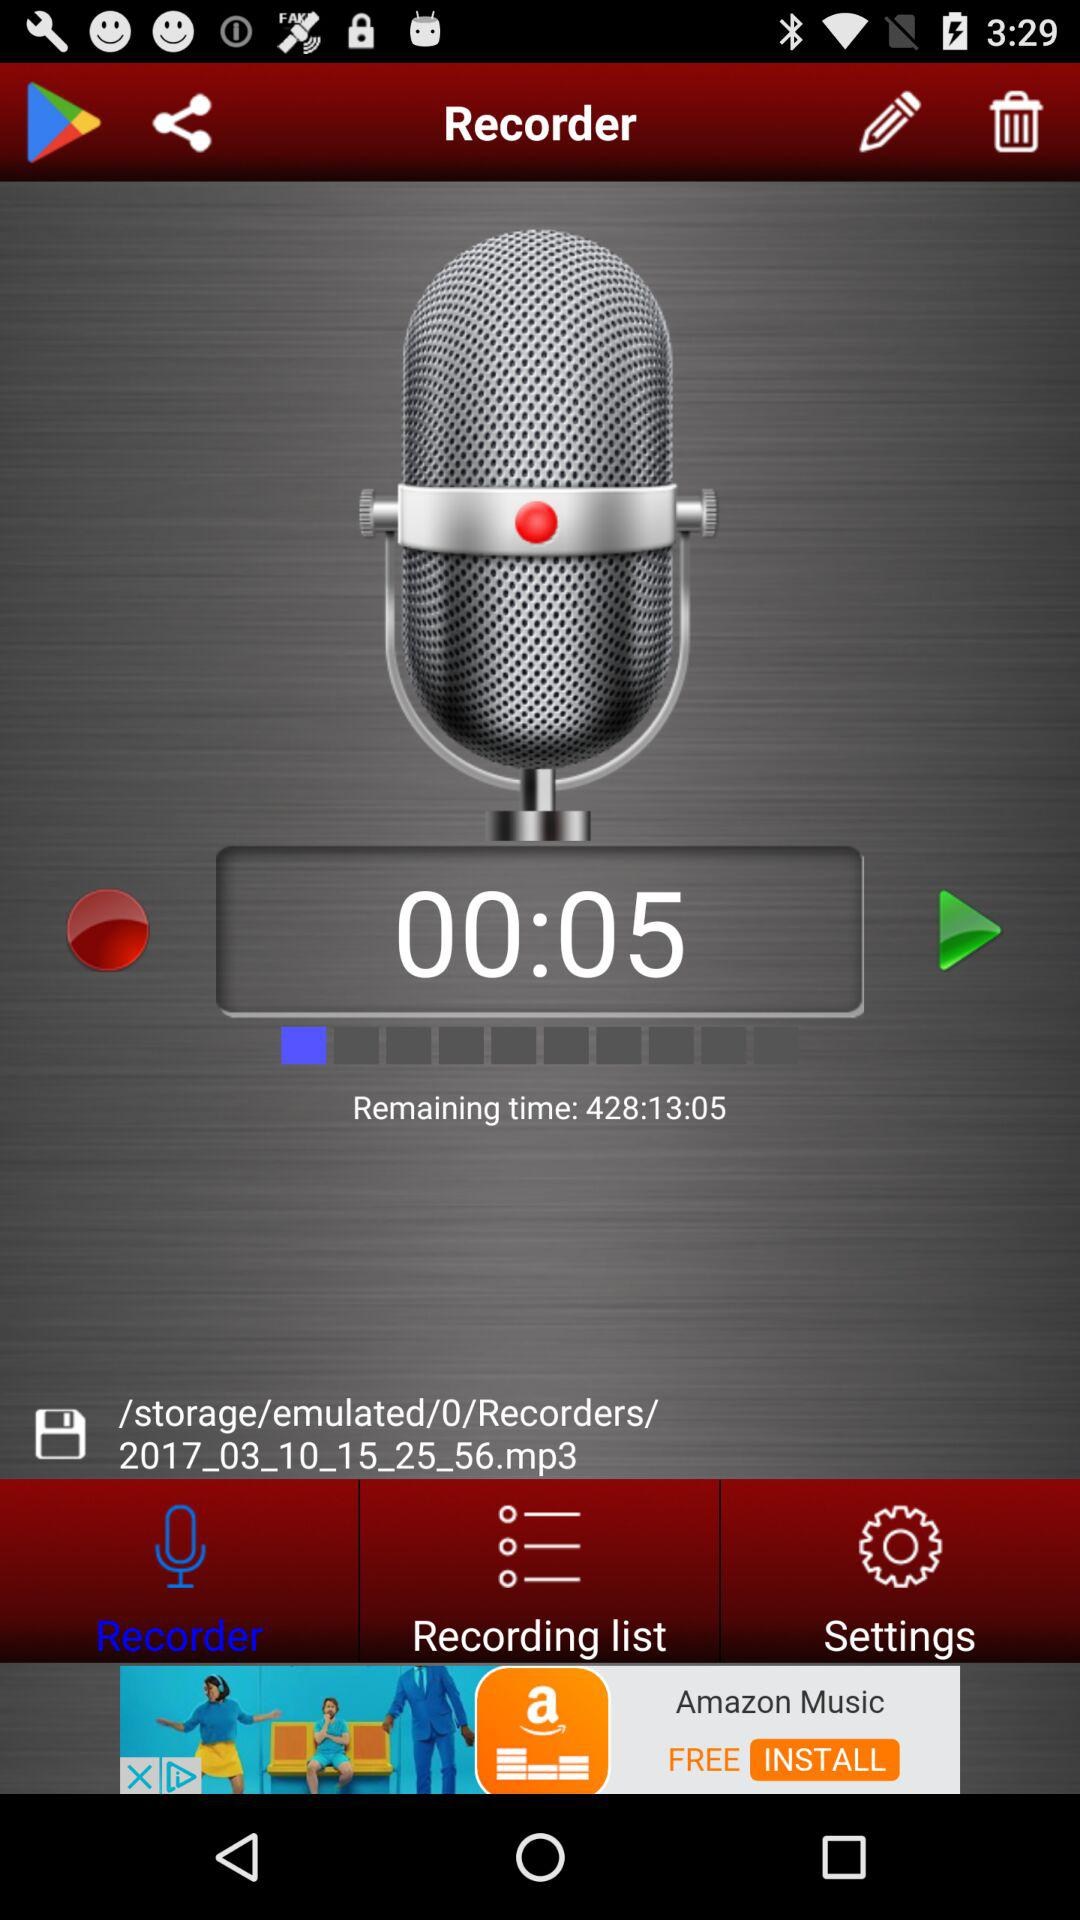How much time has already passed since the recording started?
Answer the question using a single word or phrase. 00:05 